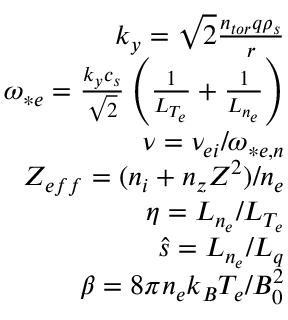Convert formula to latex. <formula><loc_0><loc_0><loc_500><loc_500>\begin{array} { r } { k _ { y } = \sqrt { 2 } \frac { n _ { t o r } q \rho _ { s } } { r } } \\ { \omega _ { * e } = \frac { k _ { y } c _ { s } } { \sqrt { 2 } } \left ( \frac { 1 } { L _ { T _ { e } } } + \frac { 1 } { L _ { n _ { e } } } \right ) } \\ { \nu = \nu _ { e i } / \omega _ { * e , n } } \\ { Z _ { e f f } = ( n _ { i } + n _ { z } Z ^ { 2 } ) / n _ { e } } \\ { \eta = L _ { n _ { e } } / L _ { T _ { e } } } \\ { \hat { s } = L _ { n _ { e } } / L _ { q } } \\ { \beta = 8 \pi n _ { e } k _ { B } T _ { e } / B _ { 0 } ^ { 2 } } \end{array}</formula> 